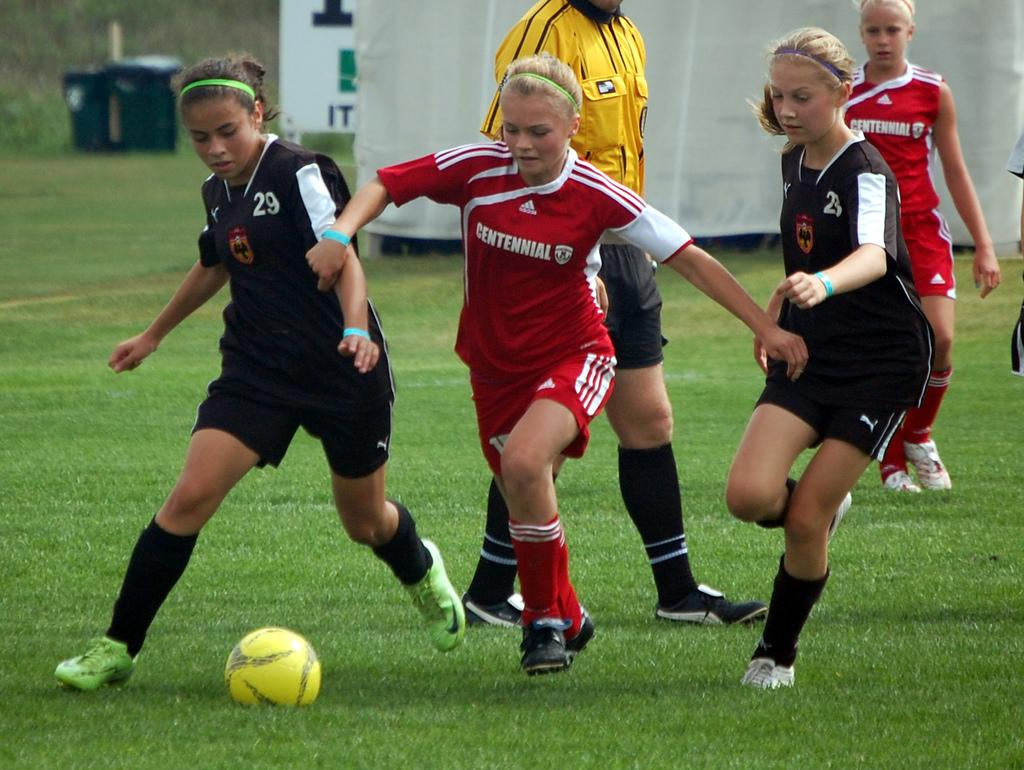<image>
Share a concise interpretation of the image provided. Three girls playing soccer with one's jersey that says Centennial. 